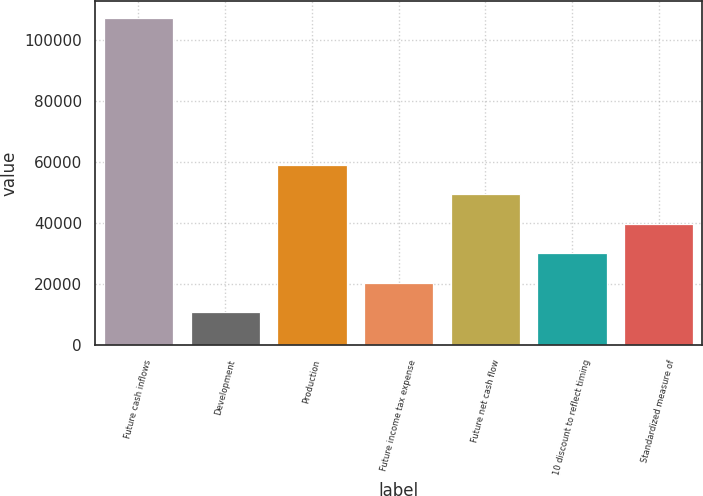<chart> <loc_0><loc_0><loc_500><loc_500><bar_chart><fcel>Future cash inflows<fcel>Development<fcel>Production<fcel>Future income tax expense<fcel>Future net cash flow<fcel>10 discount to reflect timing<fcel>Standardized measure of<nl><fcel>107218<fcel>10787<fcel>59002.5<fcel>20430.1<fcel>49359.4<fcel>30073.2<fcel>39716.3<nl></chart> 